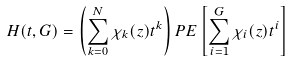Convert formula to latex. <formula><loc_0><loc_0><loc_500><loc_500>H ( t , G ) = \left ( \sum _ { k = 0 } ^ { N } \chi _ { k } ( z ) t ^ { k } \right ) P E \left [ \sum _ { i = 1 } ^ { G } \chi _ { i } ( z ) t ^ { i } \right ]</formula> 